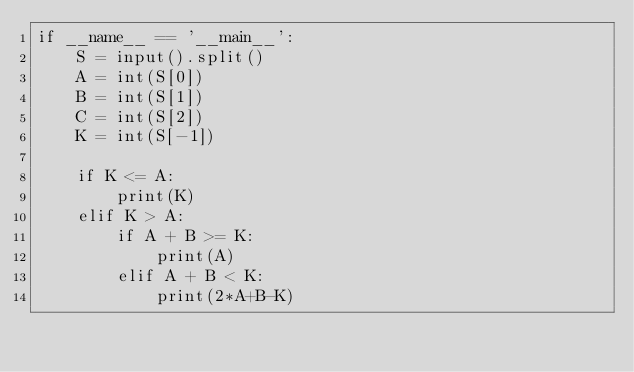Convert code to text. <code><loc_0><loc_0><loc_500><loc_500><_Python_>if __name__ == '__main__':
    S = input().split()
    A = int(S[0])
    B = int(S[1])
    C = int(S[2])
    K = int(S[-1])

    if K <= A:
        print(K)
    elif K > A:
        if A + B >= K:
            print(A)
        elif A + B < K:
            print(2*A+B-K)</code> 